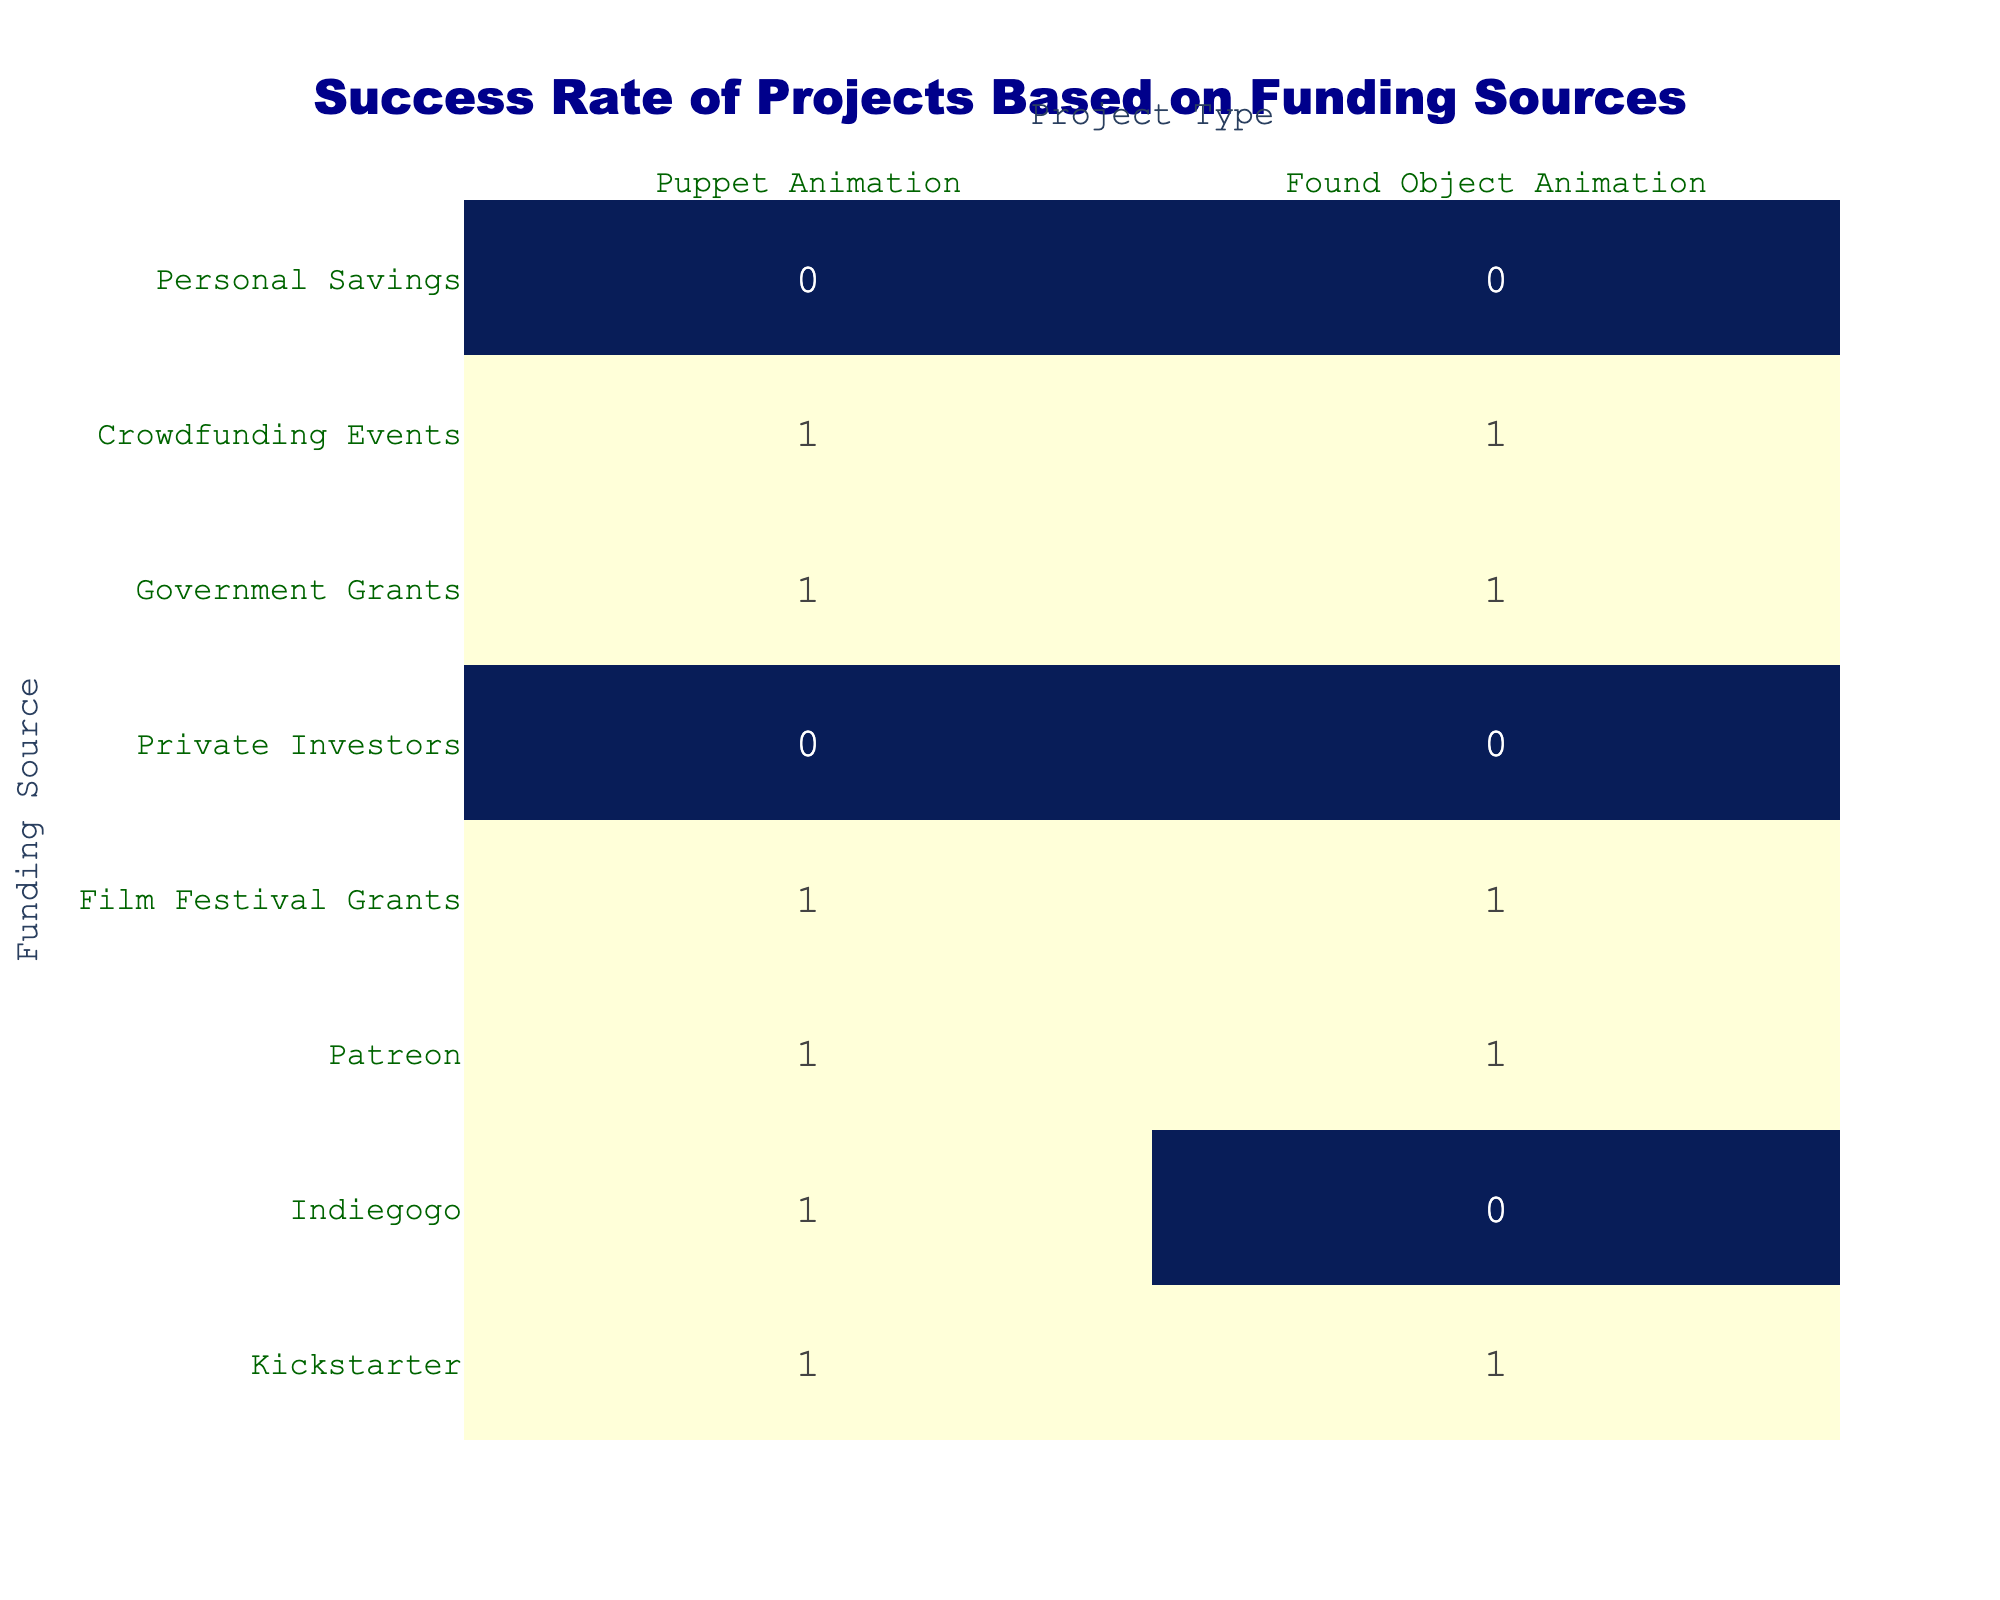What is the success rate of Puppet Animation projects funded by Kickstarter? The table shows that the success count for Puppet Animation projects funded by Kickstarter is 1 and there are no failures. Therefore, the success rate is 100%.
Answer: 100% How many funding sources successfully supported Found Object Animation projects? The table lists the funding sources for Found Object Animation, and among the eight sources, there are four that have a success count of 1: Kickstarter, Patreon, Film Festival Grants, and Government Grants. Thus, there are four successful funding sources.
Answer: 4 Is there any funding source that has only failed for Puppet Animation projects? Looking at the table, Private Investors and Personal Savings have 0 success and 1 failure for Puppet Animation projects, indicating that these sources have only failed. Therefore, the answer is yes.
Answer: Yes What is the difference in the number of successful Puppet Animation projects between Private Investors and Government Grants? For Puppet Animation, Private Investors have 0 successful projects, while Government Grants have 1. The difference in success counts between the two is 1 - 0 = 1.
Answer: 1 Which funding source had the highest success rate for Found Object Animation projects? Analyzing the table, both Kickstarter, Patreon, Film Festival Grants, and Government Grants show 100% success as they have 1 success and 0 failures. Thus, any of these sources could be considered as having the highest success rate.
Answer: Kickstarter, Patreon, Film Festival Grants, Government Grants How many projects failed under Personal Savings funding for both Puppet Animation and Found Object Animation? The table indicates that Personal Savings failed for both Puppet Animation (1 failure) and Found Object Animation (1 failure). Therefore, the total is 1 + 1 = 2 failures.
Answer: 2 Is the success rate higher for Puppet Animation projects compared to Found Object Animation projects from Indiegogo? Puppet Animation projects funded by Indiegogo have a success of 1 and Found Object Animation projects have a failure of 1. Thus, Puppet Animation has a 100% success rate while Found Object Animation has a 0% success rate. Therefore, the success rate is higher for Puppet Animation.
Answer: Yes What is the total number of successful Puppet Animation projects across all funding sources? Adding up the successful counts for Puppet Animation: Kickstarter (1), Indiegogo (1), Patreon (1), Film Festival Grants (1), Government Grants (1), and Crowdfunding Events (1) gives a total of 6 successful Puppet Animation projects.
Answer: 6 What percentage of projects for Found Object Animation were a success? There are a total of 8 Found Object Animation projects listed. Successful projects are those with 1 success: Kickstarter, Patreon, Film Festival Grants, Government Grants, and Crowdfunding Events, totaling 5. Thus, the success percentage is (5/8) * 100 = 62.5%.
Answer: 62.5% 